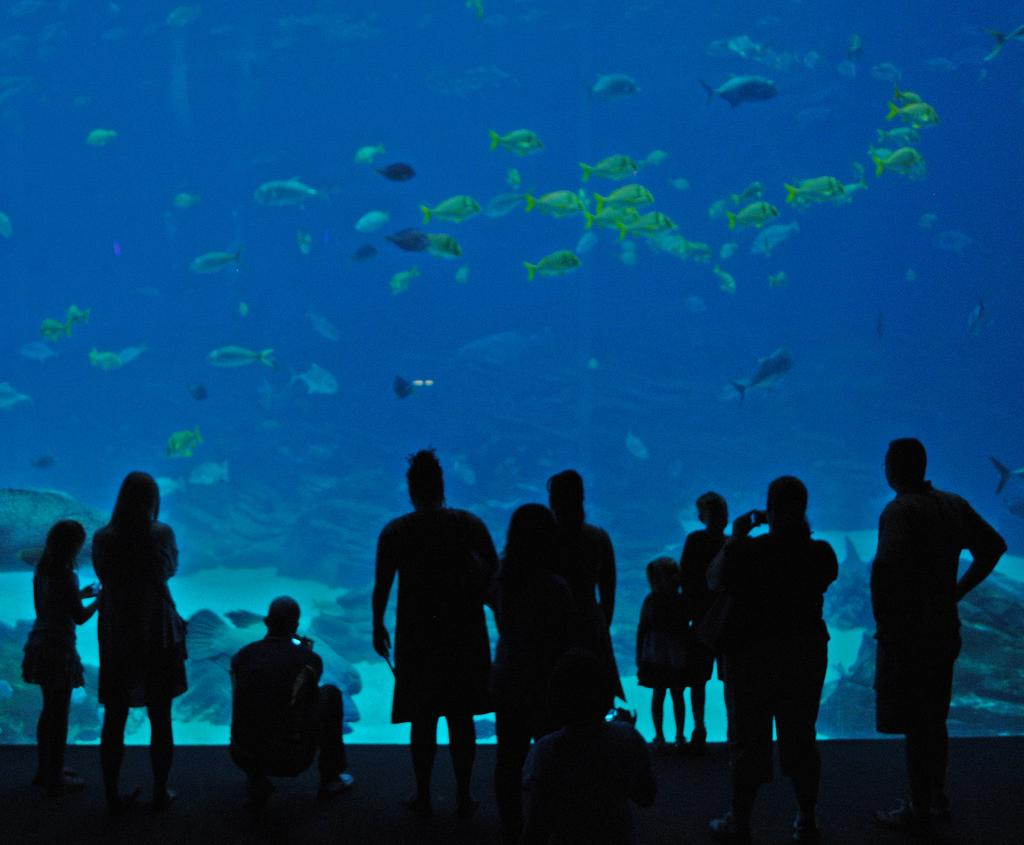What can be seen in the image involving people? There are people standing in the image. What object is present in the image that contains a liquid? There is a glass in the image that contains water. What is visible through the glass? Fishes, shells, and water are visible through the glass. What type of lamp is visible in the image? There is no lamp present in the image. What kind of structure can be seen supporting the glass? The glass is not supported by any visible structure in the image. 